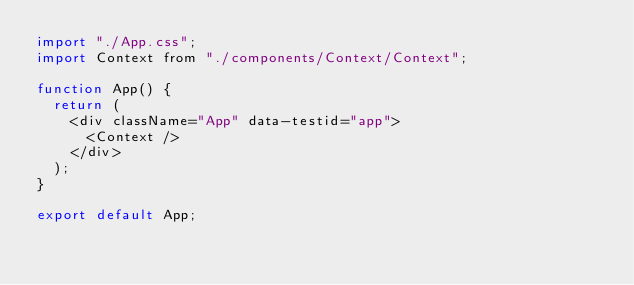Convert code to text. <code><loc_0><loc_0><loc_500><loc_500><_JavaScript_>import "./App.css";
import Context from "./components/Context/Context";

function App() {
  return (
    <div className="App" data-testid="app">
      <Context />
    </div>
  );
}

export default App;
</code> 